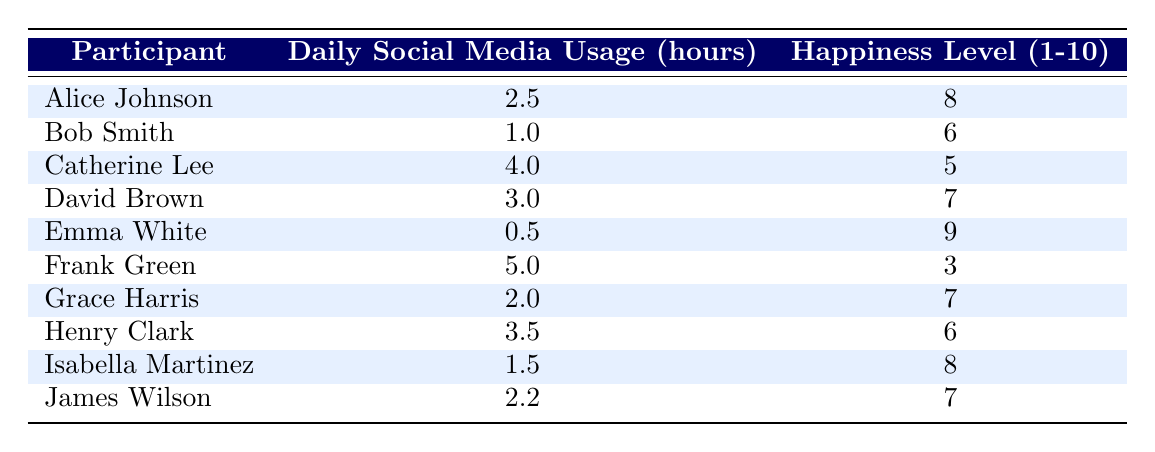What is the happiness level of Alice Johnson? By looking at the table, we can find the row for Alice Johnson, and her happiness level is listed under the 'Happiness Level (1-10)' column.
Answer: 8 What is the daily social media usage of Frank Green? The table indicates that Frank Green's daily social media usage is displayed in his corresponding row under the 'Daily Social Media Usage (hours)' column.
Answer: 5.0 How many participants reported a happiness level of 6? We need to count the number of participants who's happiness level, as indicated in the table, equals 6. From the table, Bob Smith and Henry Clark both have a happiness level of 6. Therefore, there are 2 participants.
Answer: 2 What is the average daily social media usage among all participants? To find the average, we first sum all the values in the 'Daily Social Media Usage (hours)' column: (2.5 + 1 + 4 + 3 + 0.5 + 5 + 2 + 3.5 + 1.5 + 2.2) = 24.2. There are 10 participants, so we divide the total by 10: 24.2 / 10 = 2.42.
Answer: 2.42 Is there any participant who uses social media for more than 4 hours and has a happiness level above 5? We need to examine each participant with social media usage over 4 hours. From the table, only Catherine Lee (4 hours, happiness 5) and Frank Green (5 hours, happiness 3) meet the criteria, but neither has a happiness level above 5. Therefore, the answer is no.
Answer: No Who has the highest happiness level and what is it? We look through the 'Happiness Level (1-10)' column to find the maximum value. By scanning the values, Emma White has the highest happiness level of 9.
Answer: 9 Do any participants have the same happiness level of 7? By checking the table, we can see that both David Brown and Grace Harris have a happiness level of 7. Therefore, the answer is yes as there is more than one participant with that score.
Answer: Yes What is the difference in daily social media usage between Emma White and the participant with the lowest usage? Emma White's usage is 0.5 hours, and Frank Green has the lowest usage at 5.0 hours. The difference in usage is 5.0 - 0.5 = 4.5 hours.
Answer: 4.5 